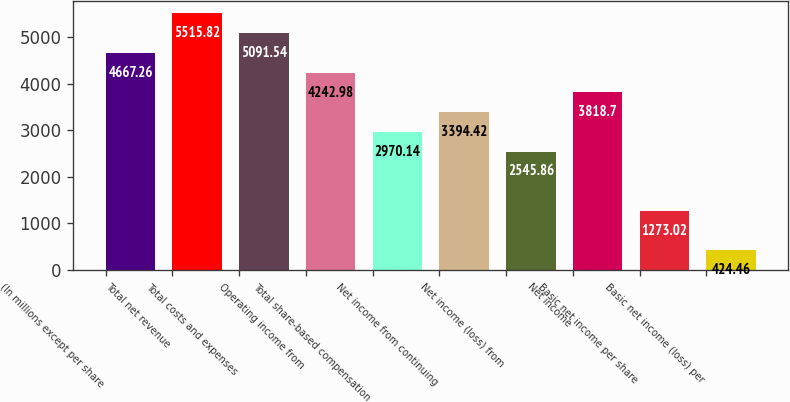Convert chart. <chart><loc_0><loc_0><loc_500><loc_500><bar_chart><fcel>(In millions except per share<fcel>Total net revenue<fcel>Total costs and expenses<fcel>Operating income from<fcel>Total share-based compensation<fcel>Net income from continuing<fcel>Net income (loss) from<fcel>Net income<fcel>Basic net income per share<fcel>Basic net income (loss) per<nl><fcel>4667.26<fcel>5515.82<fcel>5091.54<fcel>4242.98<fcel>2970.14<fcel>3394.42<fcel>2545.86<fcel>3818.7<fcel>1273.02<fcel>424.46<nl></chart> 